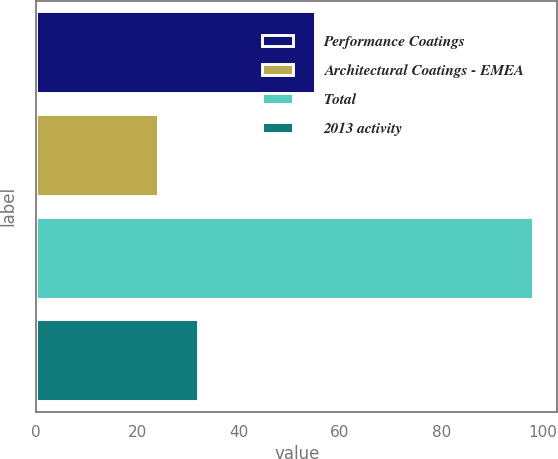Convert chart. <chart><loc_0><loc_0><loc_500><loc_500><bar_chart><fcel>Performance Coatings<fcel>Architectural Coatings - EMEA<fcel>Total<fcel>2013 activity<nl><fcel>55<fcel>24<fcel>98<fcel>32<nl></chart> 